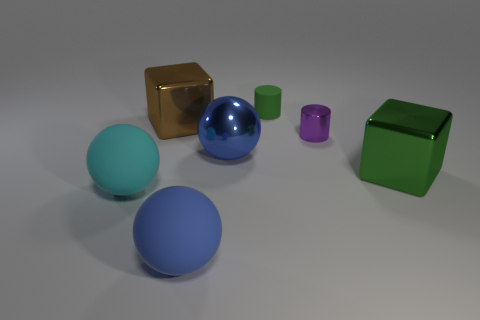Add 1 small green objects. How many objects exist? 8 Subtract all cylinders. How many objects are left? 5 Add 7 cyan matte objects. How many cyan matte objects are left? 8 Add 1 big cyan objects. How many big cyan objects exist? 2 Subtract 0 blue blocks. How many objects are left? 7 Subtract all large red balls. Subtract all blue shiny spheres. How many objects are left? 6 